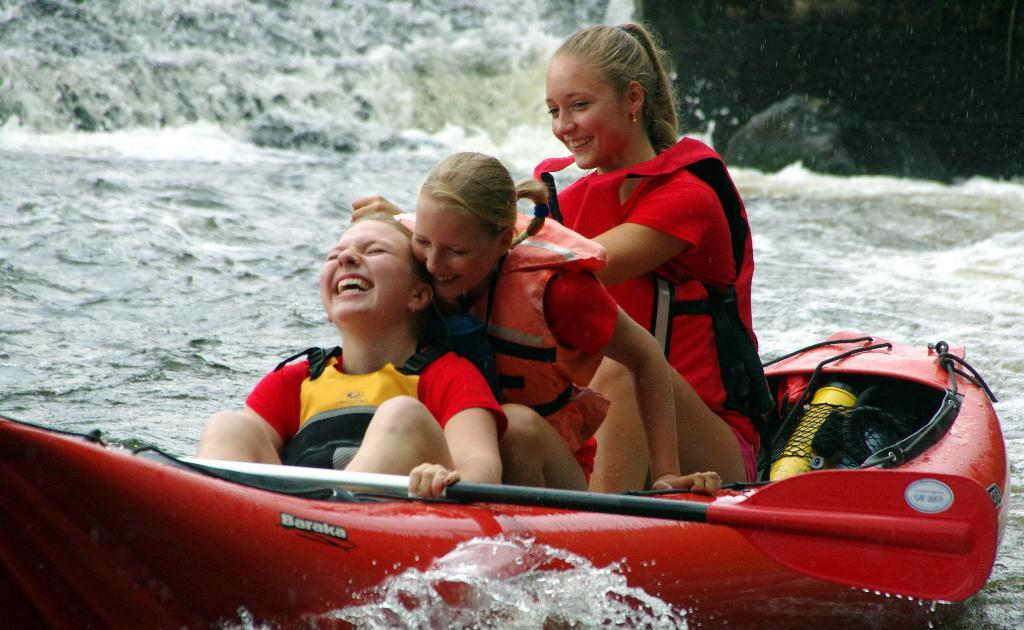What is the main subject of the image? The main subject of the image is the girls. Where are the girls located in the image? The girls are in the center of the image. What are the girls doing in the image? The girls are in a boat. What can be seen around the area of the image? There is water around the area of the image. What type of scarecrow is standing near the girls in the image? There is no scarecrow present in the image. What wish do the girls have while they are in the boat? The image does not provide any information about the girls' wishes, so it cannot be determined from the image. 